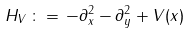Convert formula to latex. <formula><loc_0><loc_0><loc_500><loc_500>H _ { V } \, \colon = \, - \partial _ { x } ^ { 2 } - \partial _ { y } ^ { 2 } + V ( x )</formula> 